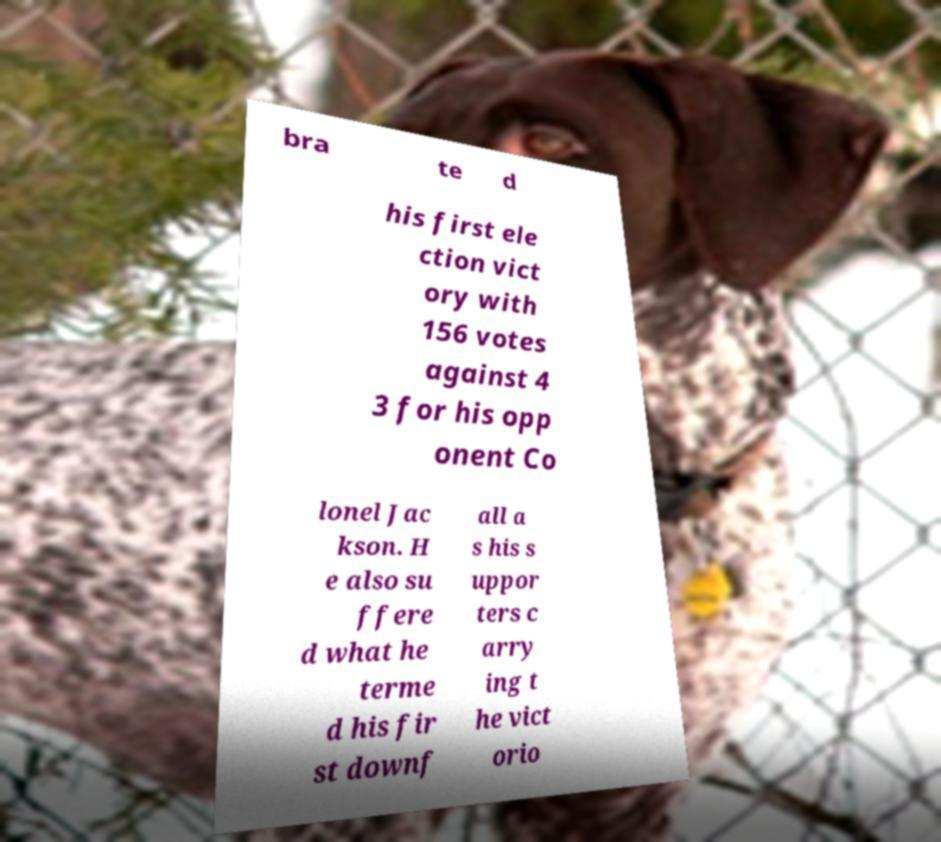What messages or text are displayed in this image? I need them in a readable, typed format. bra te d his first ele ction vict ory with 156 votes against 4 3 for his opp onent Co lonel Jac kson. H e also su ffere d what he terme d his fir st downf all a s his s uppor ters c arry ing t he vict orio 